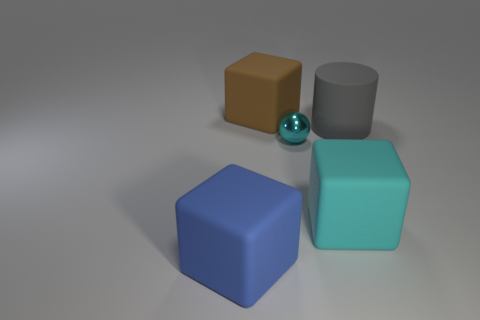Add 2 big brown blocks. How many objects exist? 7 Subtract all spheres. How many objects are left? 4 Add 4 shiny things. How many shiny things exist? 5 Subtract 0 purple cylinders. How many objects are left? 5 Subtract all large blue matte blocks. Subtract all cyan shiny things. How many objects are left? 3 Add 4 small cyan shiny objects. How many small cyan shiny objects are left? 5 